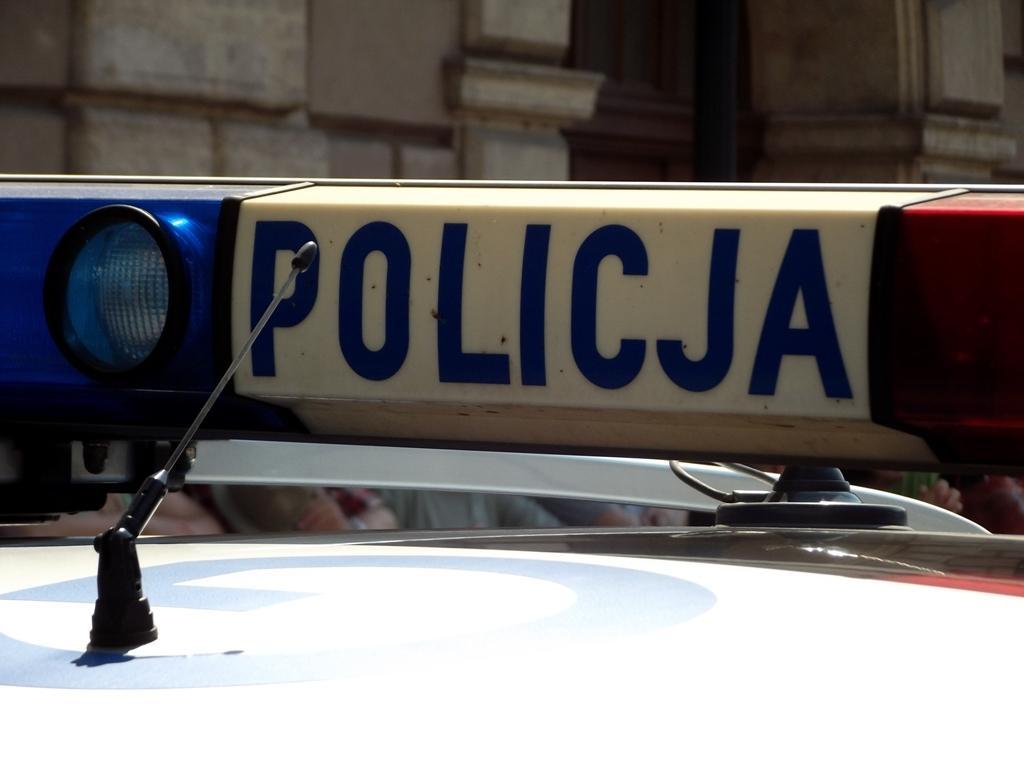Describe this image in one or two sentences. As we can see in the image there is a vehicle and buildings. 